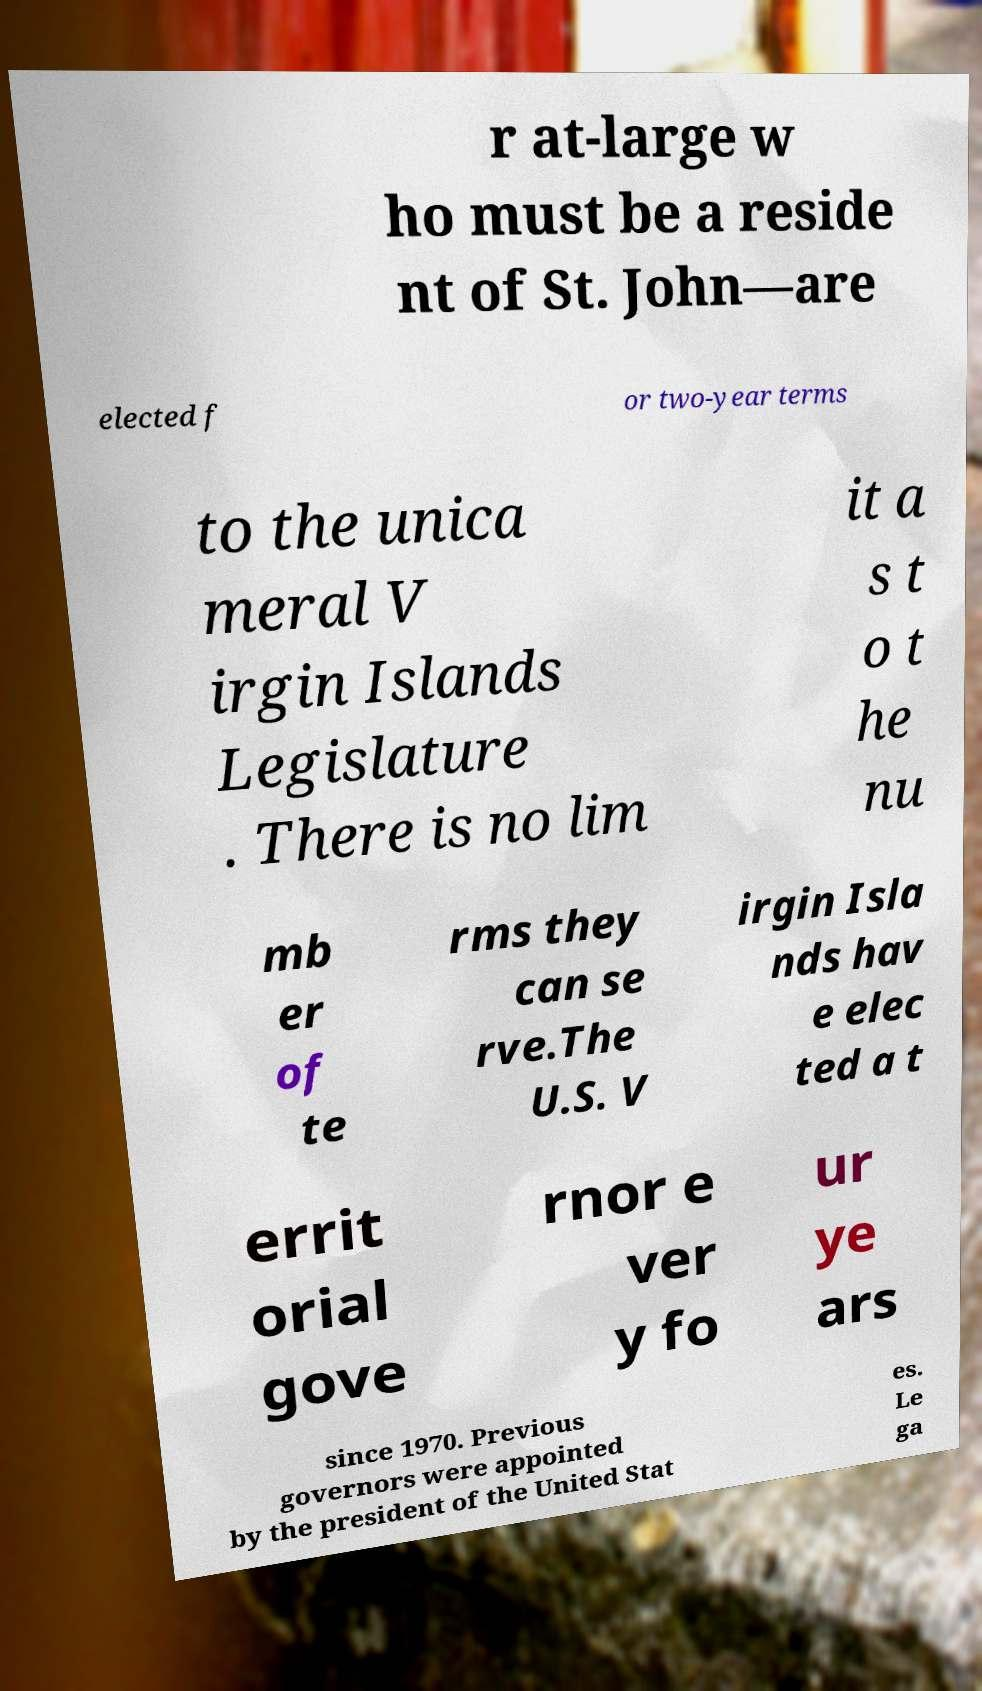Can you accurately transcribe the text from the provided image for me? r at-large w ho must be a reside nt of St. John—are elected f or two-year terms to the unica meral V irgin Islands Legislature . There is no lim it a s t o t he nu mb er of te rms they can se rve.The U.S. V irgin Isla nds hav e elec ted a t errit orial gove rnor e ver y fo ur ye ars since 1970. Previous governors were appointed by the president of the United Stat es. Le ga 